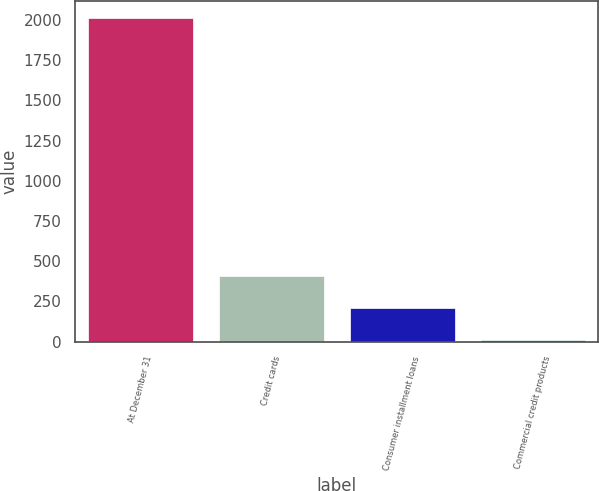Convert chart to OTSL. <chart><loc_0><loc_0><loc_500><loc_500><bar_chart><fcel>At December 31<fcel>Credit cards<fcel>Consumer installment loans<fcel>Commercial credit products<nl><fcel>2014<fcel>409.68<fcel>209.14<fcel>8.6<nl></chart> 